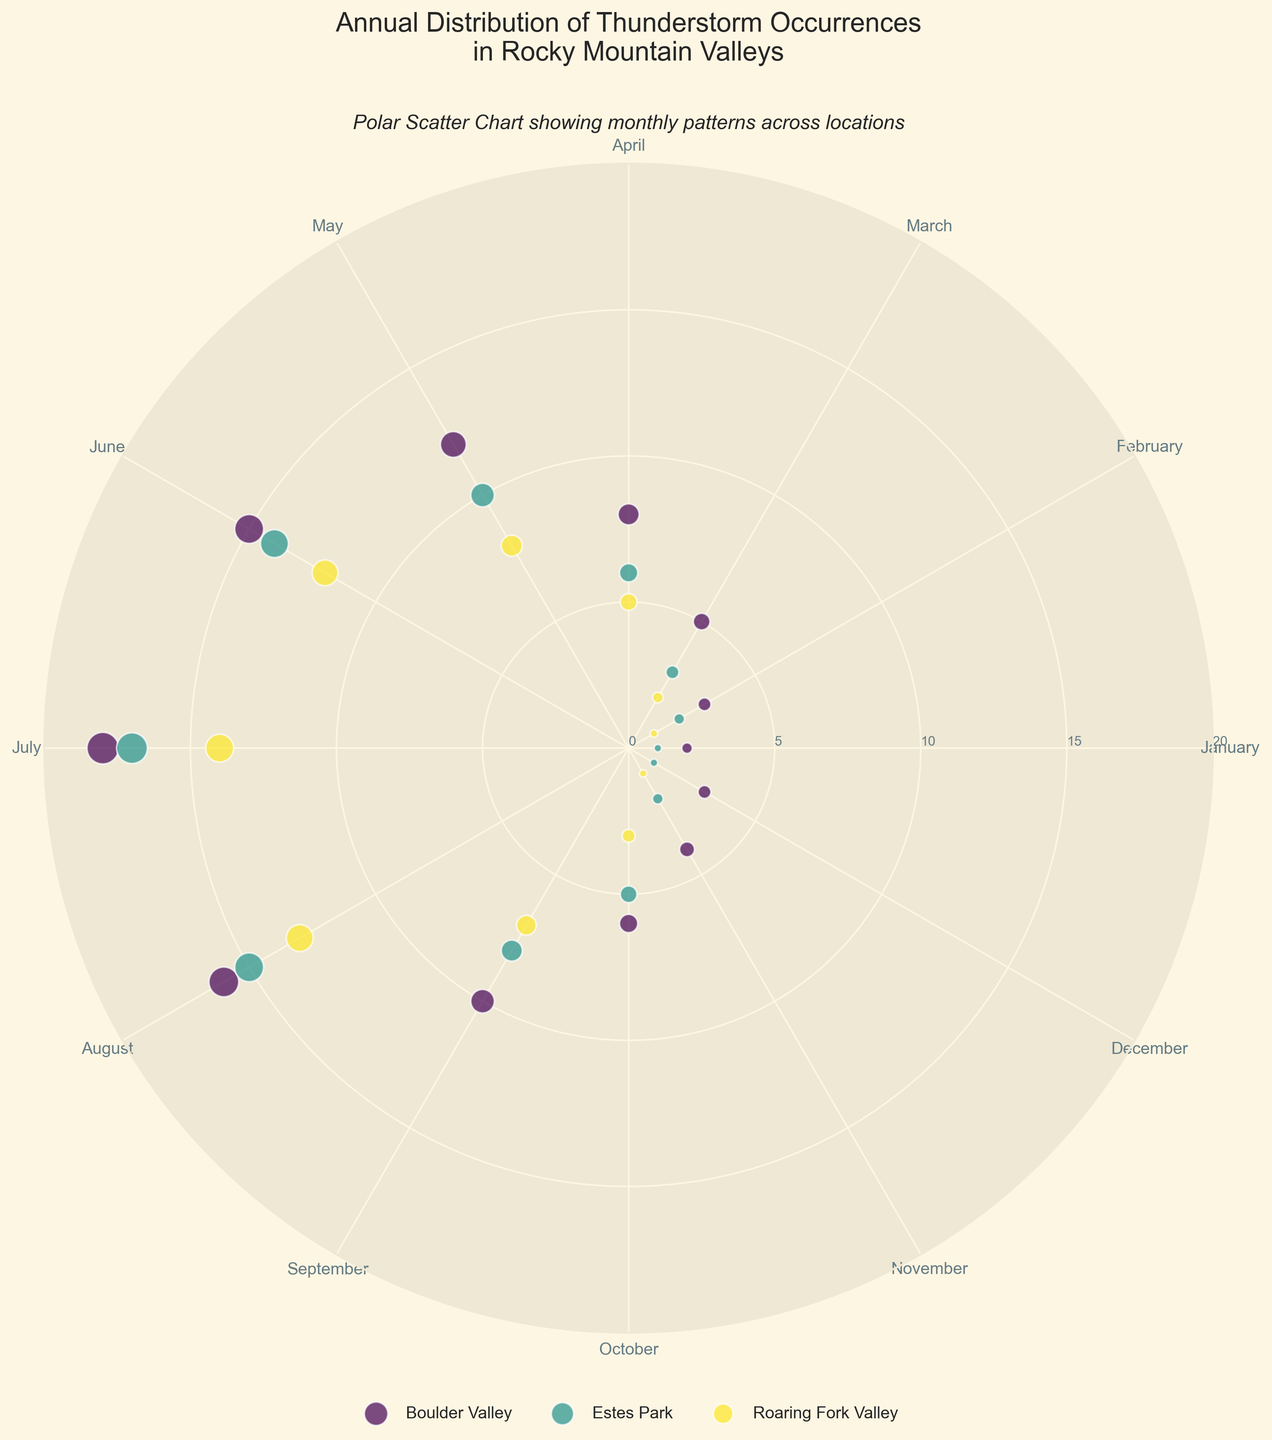What's the title of the figure? The title is positioned at the top of the figure and is clearly readable.
Answer: Annual Distribution of Thunderstorm Occurrences in Rocky Mountain Valleys Which location recorded the highest number of thunderstorms in July? To find the location with the highest number of thunderstorms in July, look at the data points plotted for July and identify the one with the largest value.
Answer: Boulder Valley On the polar scatter chart, which month has the least number of thunderstorm occurrences across all locations? Find the month where data points are positioned closest to the center of the chart, which indicates the least occurrences.
Answer: January How do the thunderstorm occurrences in August for Roaring Fork Valley compare to those in Boulder Valley? Locate the data points for August for both Roaring Fork Valley and Boulder Valley, and compare their radial distances from the center.
Answer: Roaring Fork Valley: 13, Boulder Valley: 16 (Boulder Valley has more) In which month does Estes Park experience the highest number of thunderstorms? Identify the month where the data point for Estes Park is farthest from the center on the chart.
Answer: July What is the total number of thunderstorms in Boulder Valley from January to March? Add the values of thunderstorm occurrences for Boulder Valley in January, February, and March. 2 + 3 + 5 = 10
Answer: 10 Which location shows the most significant decline in thunderstorm occurrences from July to November? Compare the data points for each location from July to November and identify the one with the largest decrease.
Answer: Boulder Valley (from 18 to 4) During which season (months) does Roaring Fork Valley experience a consistent increase in thunderstorms? Examine the data points for Roaring Fork Valley and identify months showing a steady increase, typically checking spring months (March, April, May).
Answer: Spring (March to June) How do the October thunderstorm occurrences in Estes Park compare to those in November? Locate the data points for October and November for Estes Park and compare their values.
Answer: October: 5, November: 2 (October has more) What is the average number of thunderstorms per month for Boulder Valley? Sum the monthly values of thunderstorms for Boulder Valley and divide by the number of months (12). (2+3+5+8+12+15+18+16+10+6+4+3)/12 = 102/12 = 8.5
Answer: 8.5 